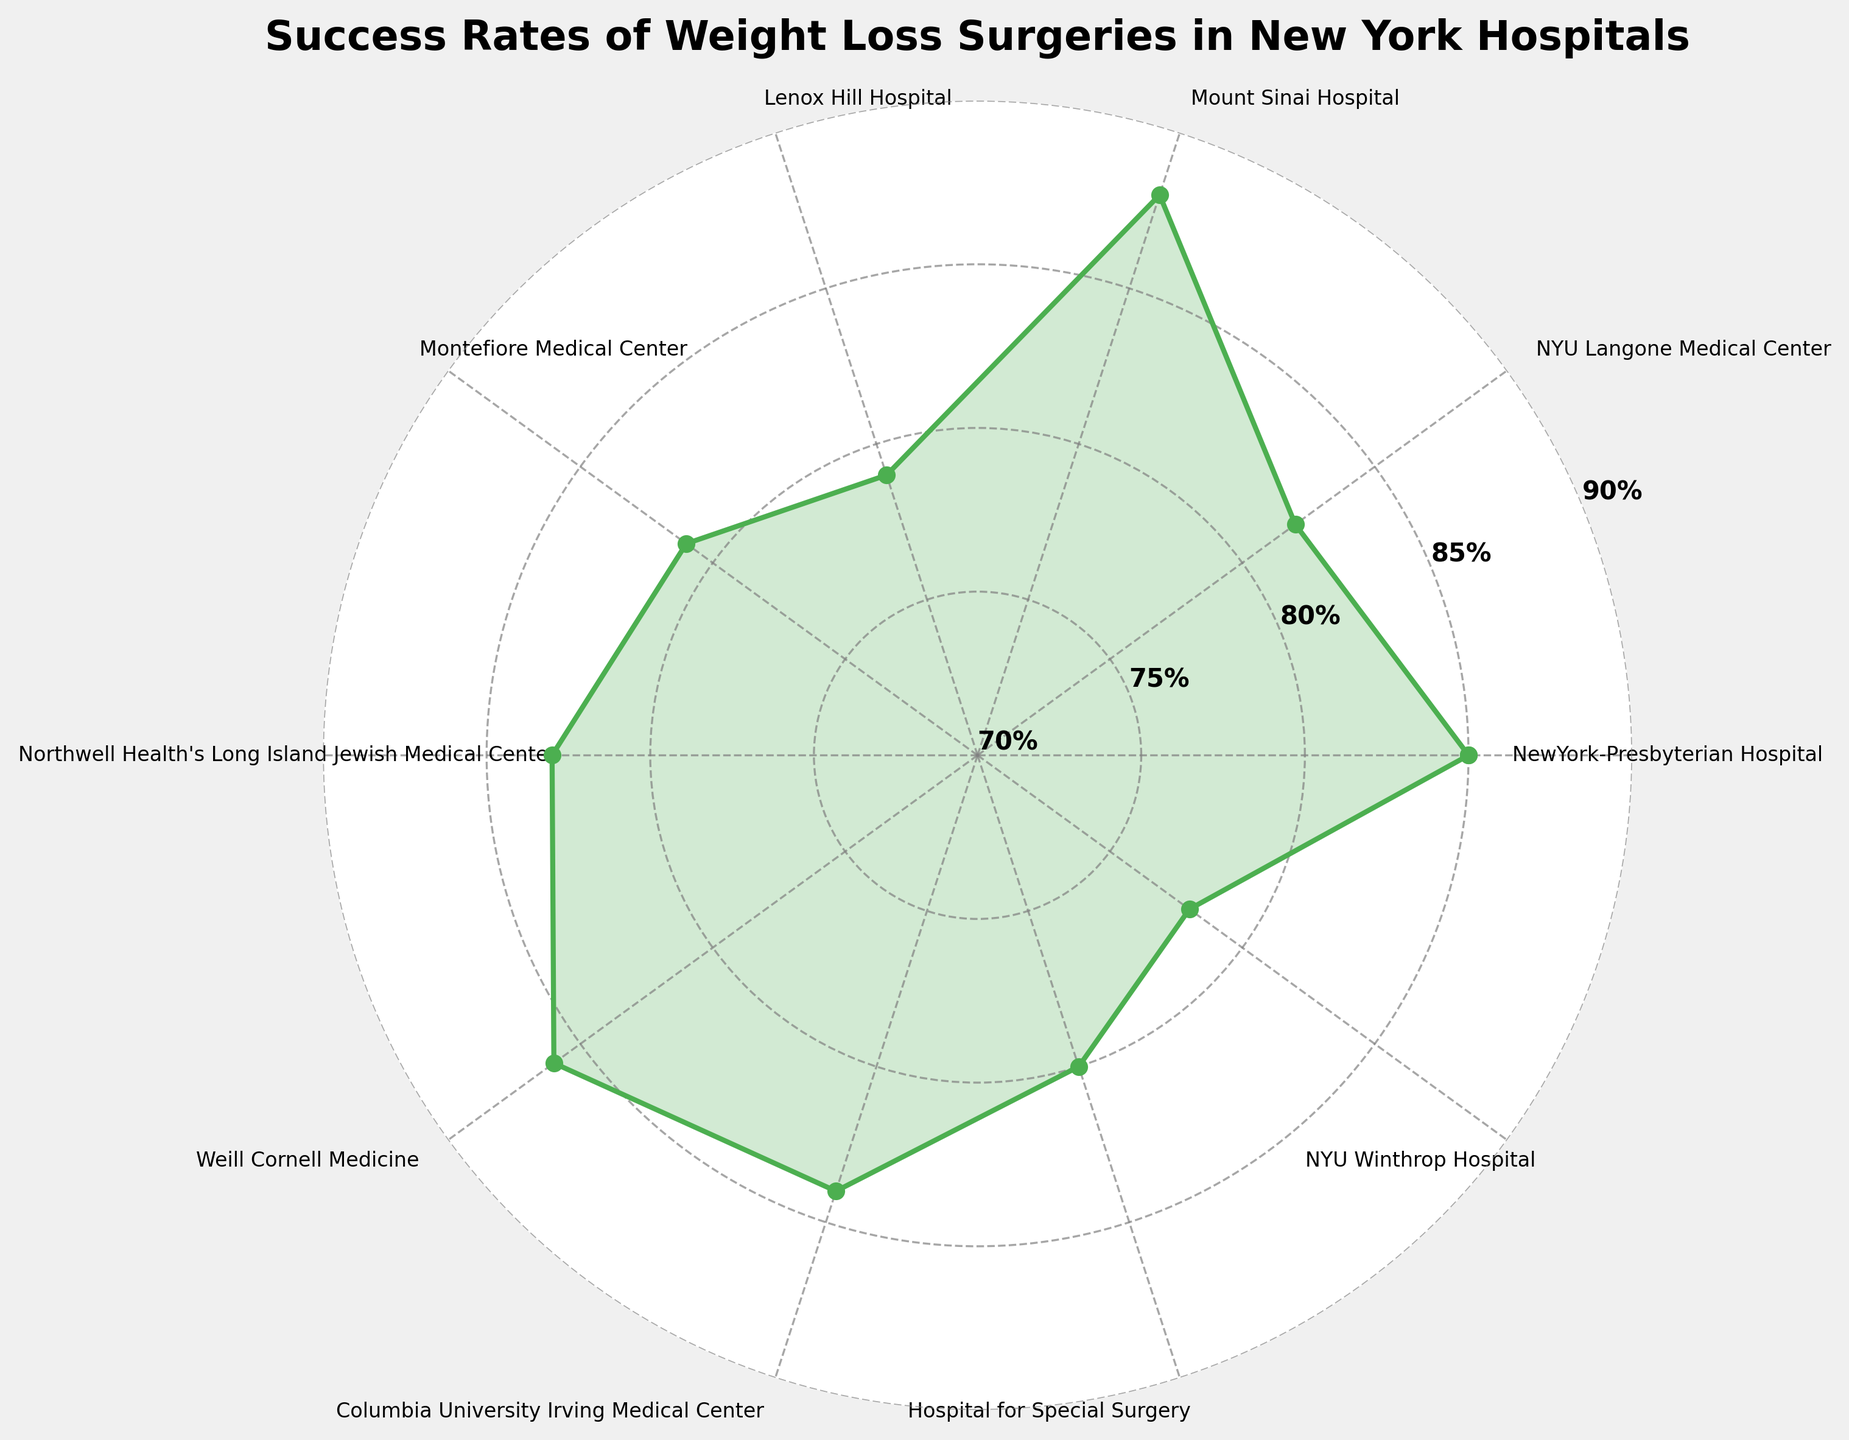Which hospital has the highest success rate for weight loss surgeries? The Mount Sinai Hospital has the highest success rate at 88%, as it is indicated by the highest peak on the gauge chart.
Answer: Mount Sinai Hospital What is the title of the chart? The title is displayed at the top of the figure and reads "Success Rates of Weight Loss Surgeries in New York Hospitals".
Answer: Success Rates of Weight Loss Surgeries in New York Hospitals What is the range of success rates depicted in the chart? The chart spans success rates from 70% to 90%, marked by the range of the radial axis in the polar plot.
Answer: 70% to 90% What is the success rate difference between Lenox Hill Hospital and NYU Winthrop Hospital? Lenox Hill Hospital has a success rate of 79% and NYU Winthrop Hospital has a success rate of 78%. The difference is 79% - 78% = 1%.
Answer: 1% Which hospital has the lowest success rate, and what is it? The NYU Winthrop Hospital has the lowest success rate at 78%, indicated by the lowest point on the gauge chart.
Answer: NYU Winthrop Hospital, 78% How many hospitals have a success rate above 85%? The hospitals with a success rate above 85% are NewYork-Presbyterian Hospital, Mount Sinai Hospital, and Weill Cornell Medicine. This makes a total of three hospitals.
Answer: 3 What is the average success rate of the hospitals? The sum of the success rates is 826%. There are 10 hospitals, so the average success rate is 826% / 10 = 82.6%.
Answer: 82.6% Which hospitals have success rates between 80% and 85%? Based on the ranges shown, the hospitals within 80%-85% are NYU Langone Medical Center (82%), Montefiore Medical Center (81%), Northwell Health's Long Island Jewish Medical Center (83%), Columbia University Irving Medical Center (84%), Hospital for Special Surgery (80%).
Answer: NYU Langone Medical Center, Montefiore Medical Center, Northwell Health's Long Island Jewish Medical Center, Columbia University Irving Medical Center, Hospital for Special Surgery How does the success rate of Weill Cornell Medicine compare to that of NYU Winthrop Hospital? Weill Cornell Medicine has a success rate of 86%, while NYU Winthrop Hospital has a success rate of 78%. Weill Cornell Medicine's success rate is higher by 86% - 78% = 8%.
Answer: Weill Cornell Medicine's success rate is higher by 8% What is the success rate trend observed among the hospitals? Overall, the success rates range moderately high between 78% and 88%, showing that most hospitals in New York are achieving success rates in the upper 70s to upper 80s percentile for weight loss surgeries.
Answer: Moderately high success rates between 78% and 88% 